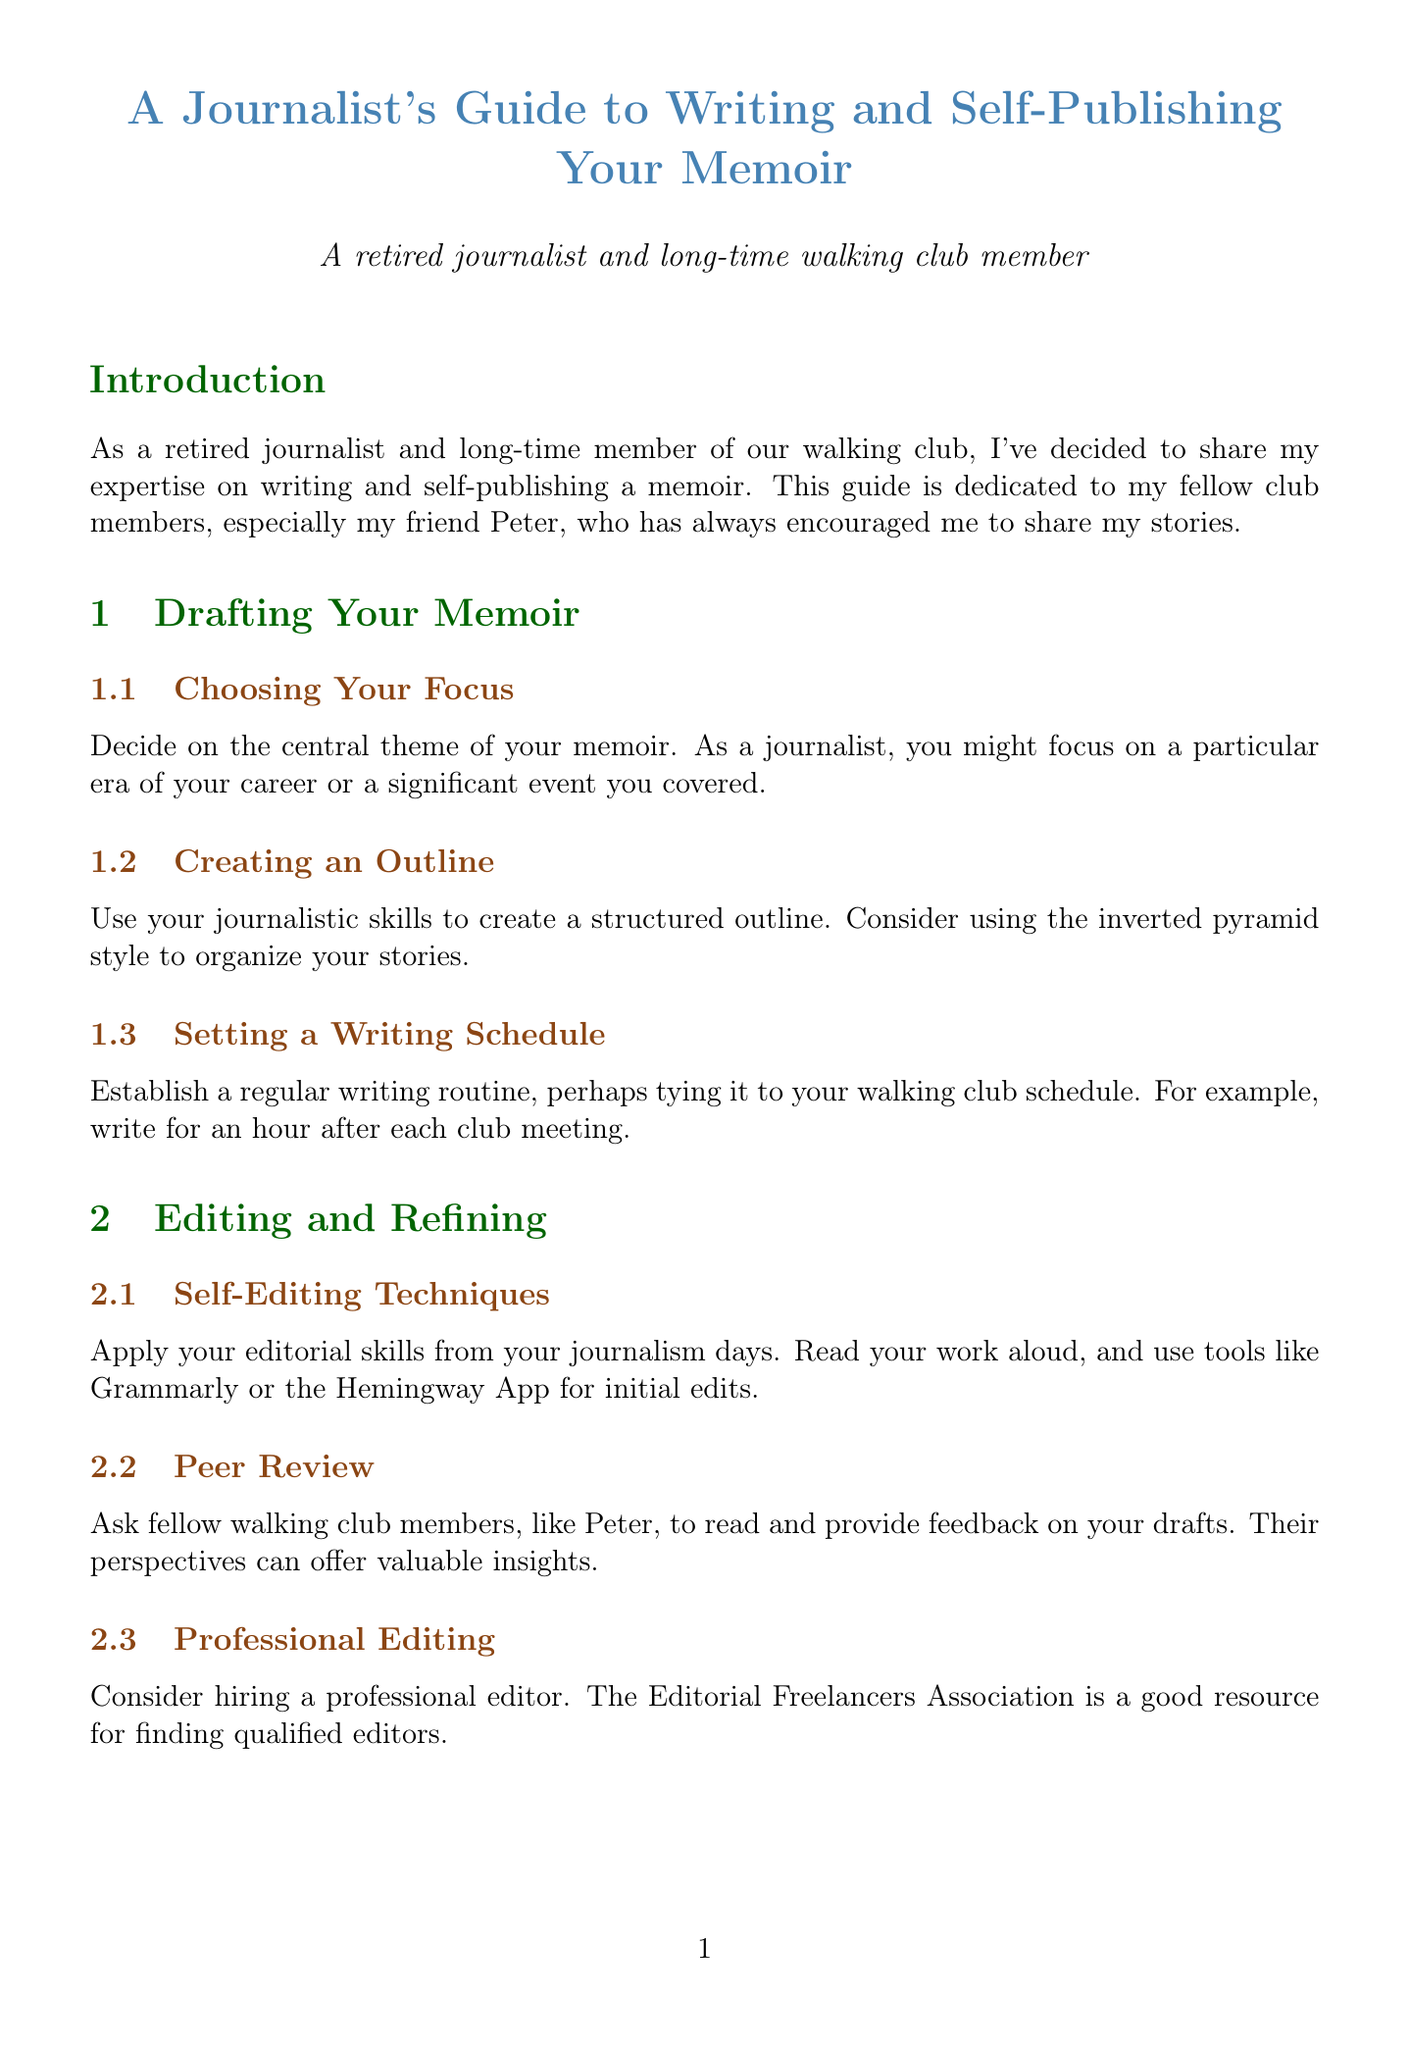What is the title of the guide? The title of the guide is stated at the beginning of the document, introducing the subject it covers.
Answer: A Journalist's Guide to Writing and Self-Publishing Your Memoir Who is the guide dedicated to? The introduction mentions that the guide is dedicated to fellow club members, particularly a specific friend.
Answer: Peter What should be established to create a writing routine? The document suggests a specific method to establish a writing routine, tying it to a regular event.
Answer: Regular writing routine Which platform is recommended for self-publishing? The section on self-publishing lists specific platforms that can be researched for self-publishing options.
Answer: Amazon Kindle Direct Publishing What tools are mentioned for editing? The editing section of the document provides a list of tools to assist with the editing process.
Answer: Grammarly, ProWritingAid, Hemingway App What is the purpose of the peer review section? The document explains the role of peer reviews in the writing process, specifically who to approach for feedback.
Answer: Valuable insights How can one leverage their network according to the marketing strategies? The marketing section outlines methods to utilize personal networks for promotional activities.
Answer: Promote your book What is the concluding advice related to the skills honed as a journalist? The conclusion offers specific guidance on the transferable skills that can aid in memoir writing.
Answer: Enjoy the process Which software is listed for writing? The resources section includes various types of software useful for the writing process.
Answer: Scrivener, Microsoft Word, Google Docs 